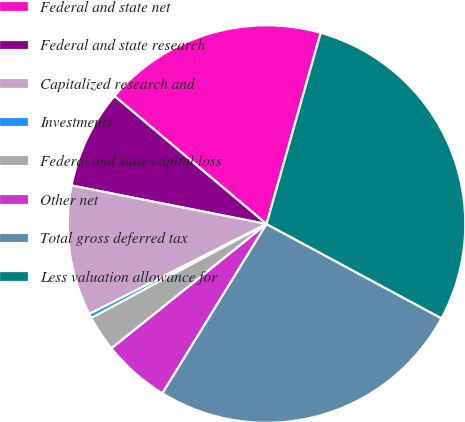<chart> <loc_0><loc_0><loc_500><loc_500><pie_chart><fcel>Federal and state net<fcel>Federal and state research<fcel>Capitalized research and<fcel>Investments<fcel>Federal and state capital loss<fcel>Other net<fcel>Total gross deferred tax<fcel>Less valuation allowance for<nl><fcel>18.26%<fcel>8.03%<fcel>10.58%<fcel>0.36%<fcel>2.92%<fcel>5.47%<fcel>25.91%<fcel>28.47%<nl></chart> 